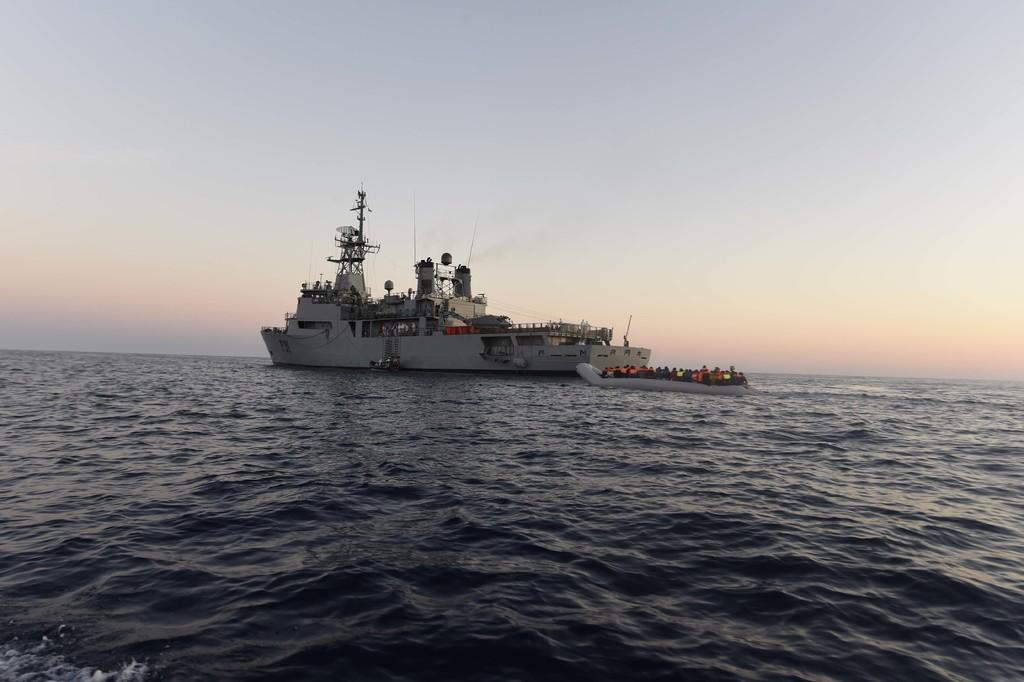What is the main subject of the image? The main subject of the image is water. What is located on the water in the image? There is a battle-cruiser on the water. What is visible at the top of the image? The sky is visible at the top of the image. What type of boundary can be seen in the image? There is no boundary present in the image; it features water, a battle-cruiser, and the sky. What game is being played on the battle-cruiser in the image? There is no game being played on the battle-cruiser in the image; it is a stationary object on the water. 